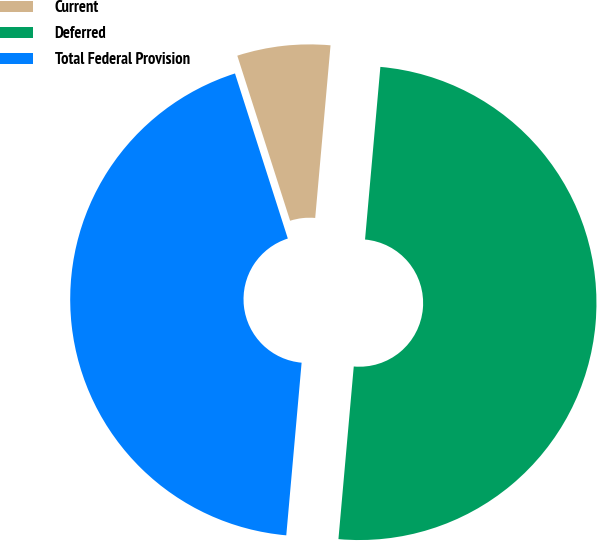Convert chart to OTSL. <chart><loc_0><loc_0><loc_500><loc_500><pie_chart><fcel>Current<fcel>Deferred<fcel>Total Federal Provision<nl><fcel>6.34%<fcel>50.0%<fcel>43.66%<nl></chart> 